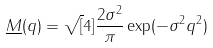Convert formula to latex. <formula><loc_0><loc_0><loc_500><loc_500>\underline { M } ( q ) = \sqrt { [ } 4 ] { \frac { 2 \sigma ^ { 2 } } { \pi } } \exp ( - \sigma ^ { 2 } q ^ { 2 } )</formula> 